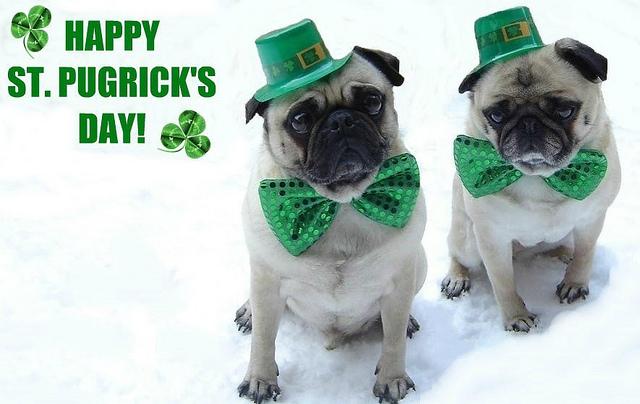What kind of dogs is in the picture?
Quick response, please. Pug. How many animals are in the picture?
Concise answer only. 2. What are these dogs wearing around their necks?
Quick response, please. Bow ties. 